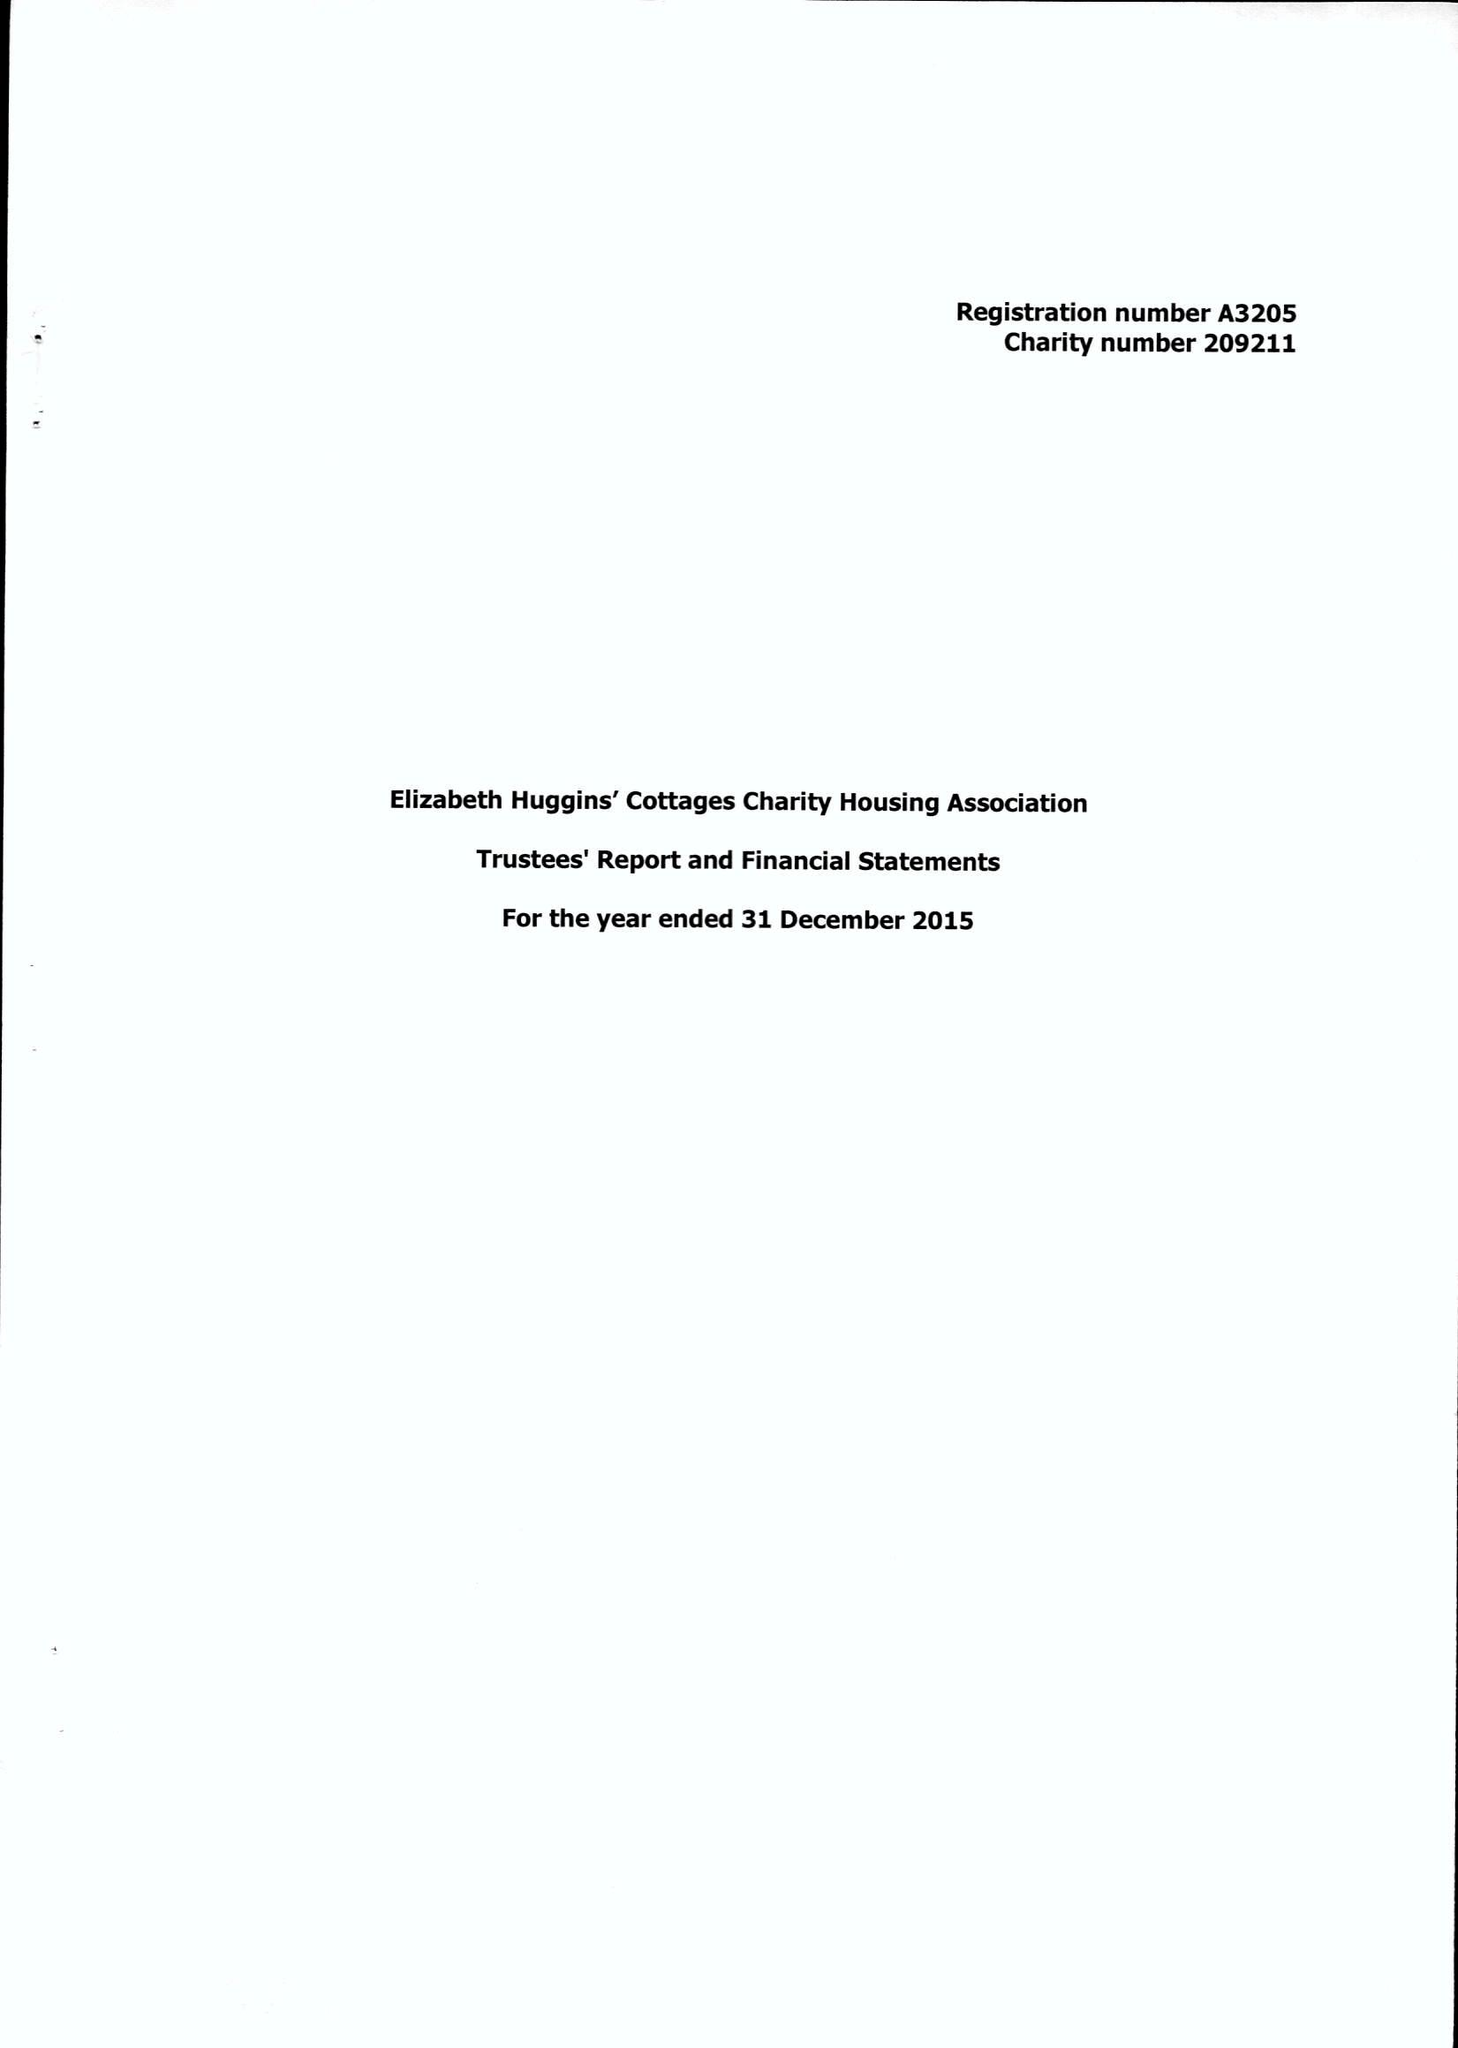What is the value for the address__post_town?
Answer the question using a single word or phrase. GRAVESEND 